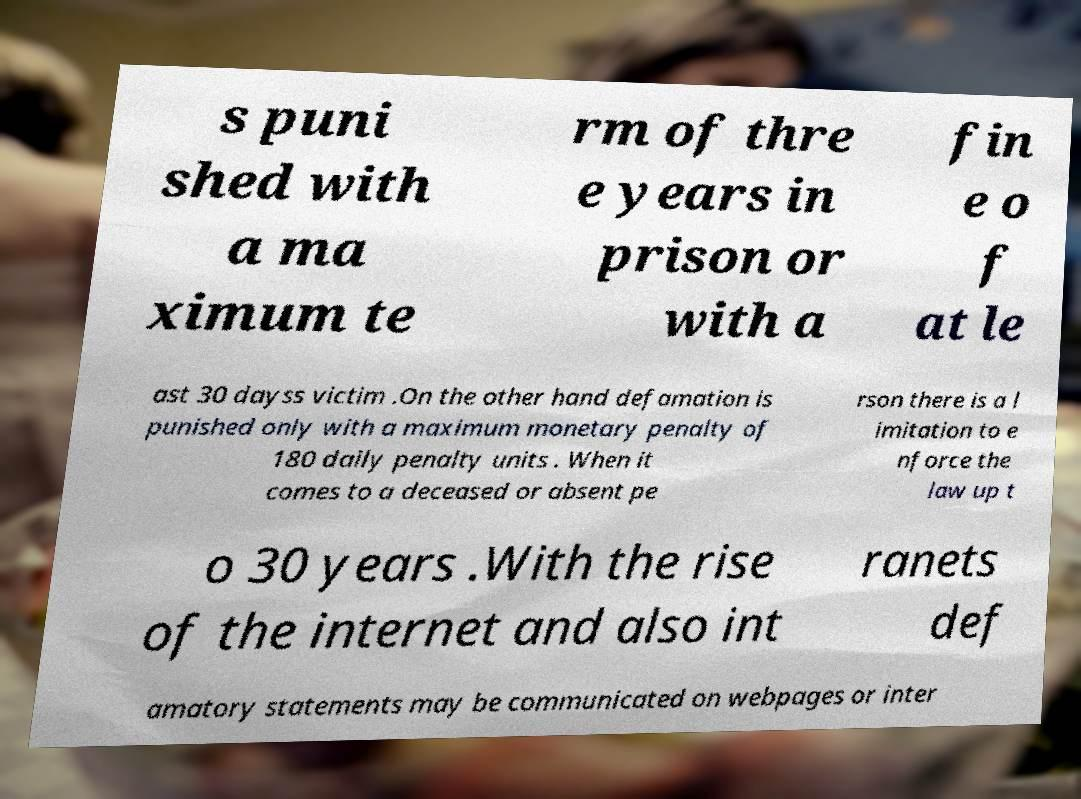Please identify and transcribe the text found in this image. s puni shed with a ma ximum te rm of thre e years in prison or with a fin e o f at le ast 30 dayss victim .On the other hand defamation is punished only with a maximum monetary penalty of 180 daily penalty units . When it comes to a deceased or absent pe rson there is a l imitation to e nforce the law up t o 30 years .With the rise of the internet and also int ranets def amatory statements may be communicated on webpages or inter 